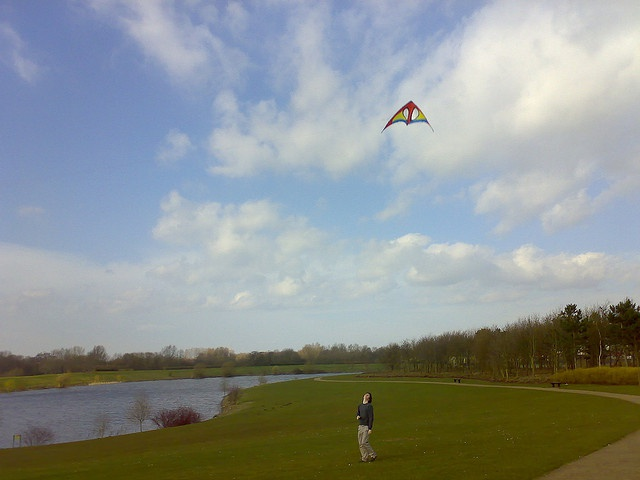Describe the objects in this image and their specific colors. I can see people in gray, black, and darkgreen tones, kite in gray, olive, maroon, brown, and darkgray tones, bench in black, darkgreen, and gray tones, and bench in black, darkgreen, and gray tones in this image. 